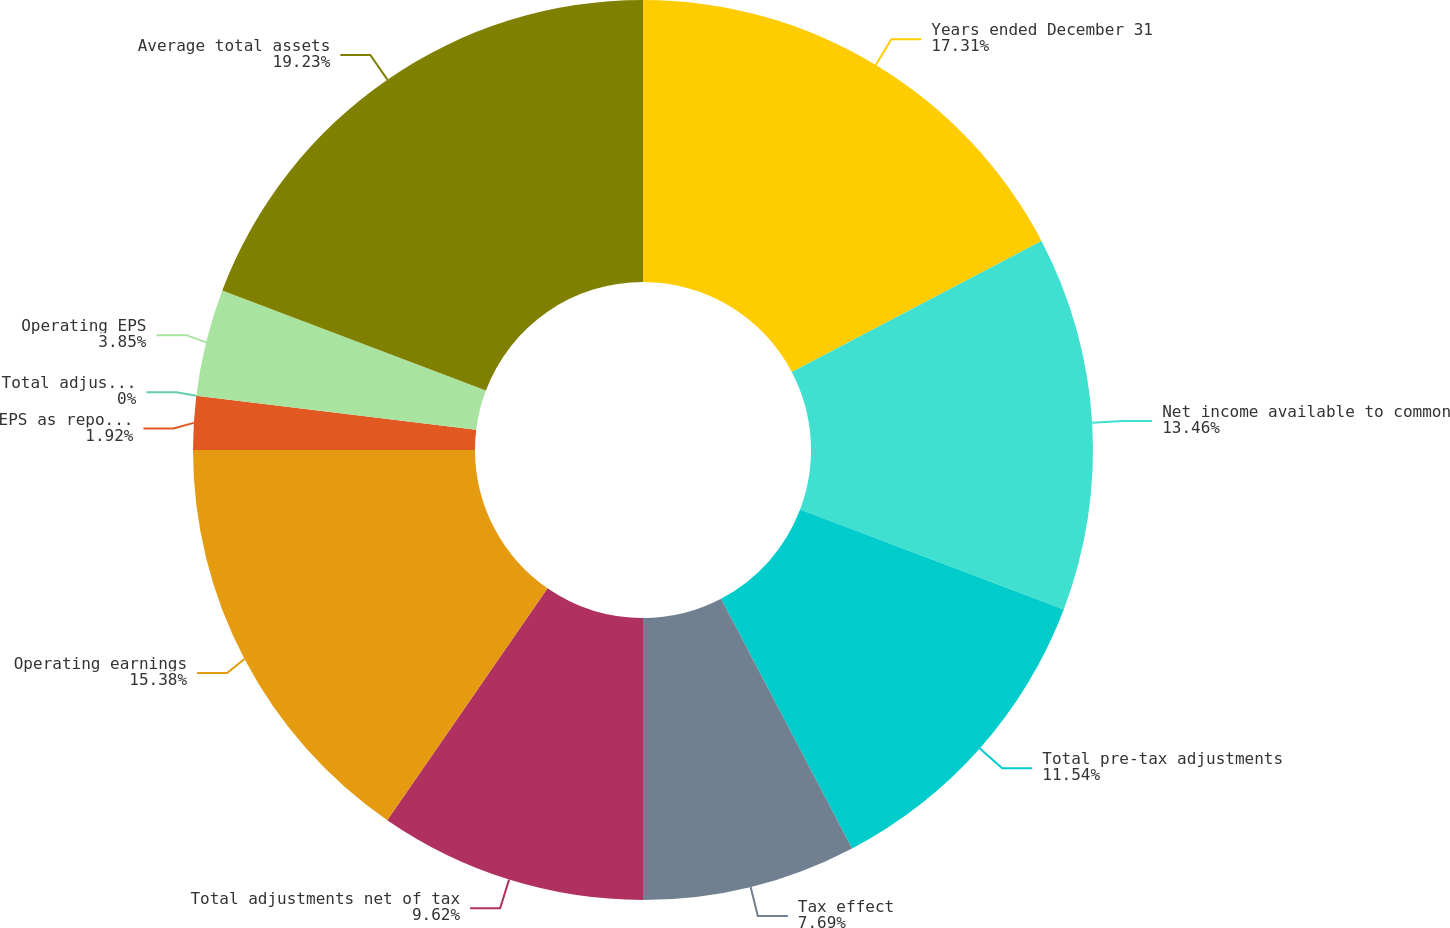Convert chart to OTSL. <chart><loc_0><loc_0><loc_500><loc_500><pie_chart><fcel>Years ended December 31<fcel>Net income available to common<fcel>Total pre-tax adjustments<fcel>Tax effect<fcel>Total adjustments net of tax<fcel>Operating earnings<fcel>EPS as reported<fcel>Total adjustments per share<fcel>Operating EPS<fcel>Average total assets<nl><fcel>17.31%<fcel>13.46%<fcel>11.54%<fcel>7.69%<fcel>9.62%<fcel>15.38%<fcel>1.92%<fcel>0.0%<fcel>3.85%<fcel>19.23%<nl></chart> 